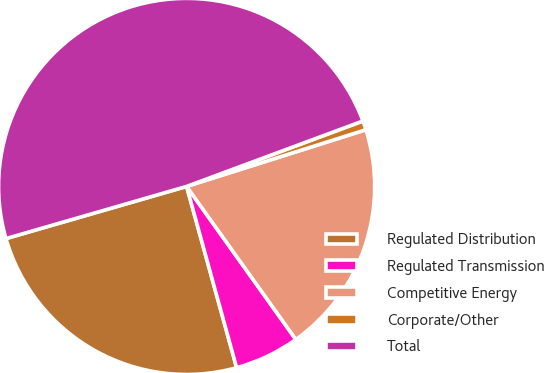<chart> <loc_0><loc_0><loc_500><loc_500><pie_chart><fcel>Regulated Distribution<fcel>Regulated Transmission<fcel>Competitive Energy<fcel>Corporate/Other<fcel>Total<nl><fcel>24.81%<fcel>5.58%<fcel>20.01%<fcel>0.78%<fcel>48.82%<nl></chart> 